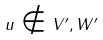Convert formula to latex. <formula><loc_0><loc_0><loc_500><loc_500>u \notin V ^ { \prime } , W ^ { \prime }</formula> 